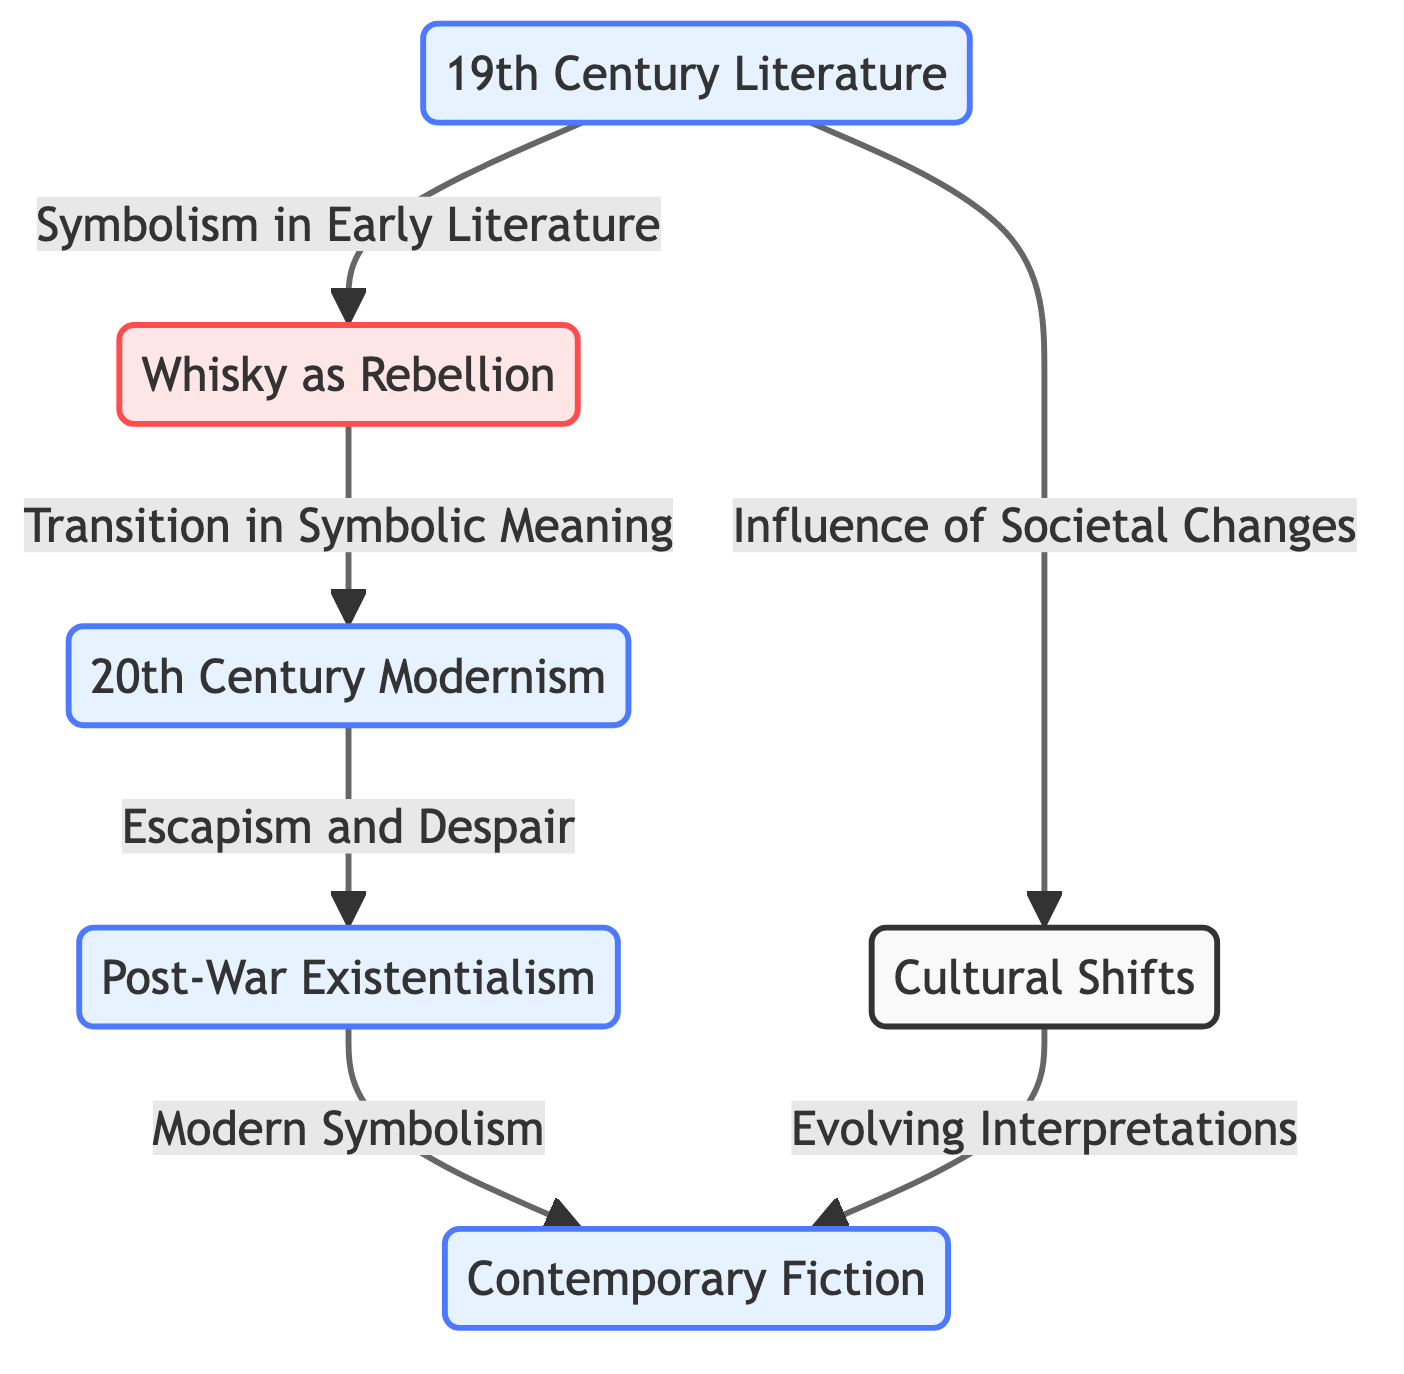What is the first era depicted in the diagram? The first era node in the diagram is labeled "19th Century Literature." It is placed at the top of the flowchart, indicating it is the starting point.
Answer: 19th Century Literature How many symbolic meanings are indicated in the diagram? There are two symbolic meanings explicitly indicated: "Whisky as Rebellion" and "Modern Symbolism." These are represented as separate nodes connected to different eras.
Answer: 2 What connects "19th Century Literature" to "20th Century Modernism"? The connection between "19th Century Literature" and "20th Century Modernism" is labeled "Transition in Symbolic Meaning," showing the progression of whisky symbolism from the 19th to the 20th century.
Answer: Transition in Symbolic Meaning Which era is associated with "Escapism and Despair"? The node labeled "Escapism and Despair" is directly connected to the "20th Century Modernism" era, indicating it is part of this time period's themes regarding whisky.
Answer: 20th Century Modernism What is the relationship between "Cultural Shifts" and "Contemporary Fiction"? "Cultural Shifts" serves as a transitional node that impacts "Contemporary Fiction." It connects with an arrow labeled "Evolving Interpretations," indicating that cultural changes influence the symbolic use of whisky in contemporary works.
Answer: Evolving Interpretations Which node indicates the influence of societal changes? The node labeled "Influence of Societal Changes" is directly connected to "19th Century Literature," showing its impact on early whisky symbolism in literature.
Answer: Influence of Societal Changes What change is depicted from "Post-War Existentialism" to "Contemporary Fiction"? The diagram illustrates a progression labeled "Modern Symbolism" that connects "Post-War Existentialism" to "Contemporary Fiction," indicating a shift in how whisky is symbolized from one era to the next.
Answer: Modern Symbolism How are the eras organized in the diagram? The eras are organized sequentially from "19th Century Literature" at the top to "Contemporary Fiction" at the bottom, reflecting a chronological evolution in whisky symbolism.
Answer: Chronological progression What is the last thematic element connected in the diagram? The last thematic element depicted in the diagram is "Contemporary Fiction," indicating it is the final area of focus concerning whisky symbolism as per the evolution shown.
Answer: Contemporary Fiction 